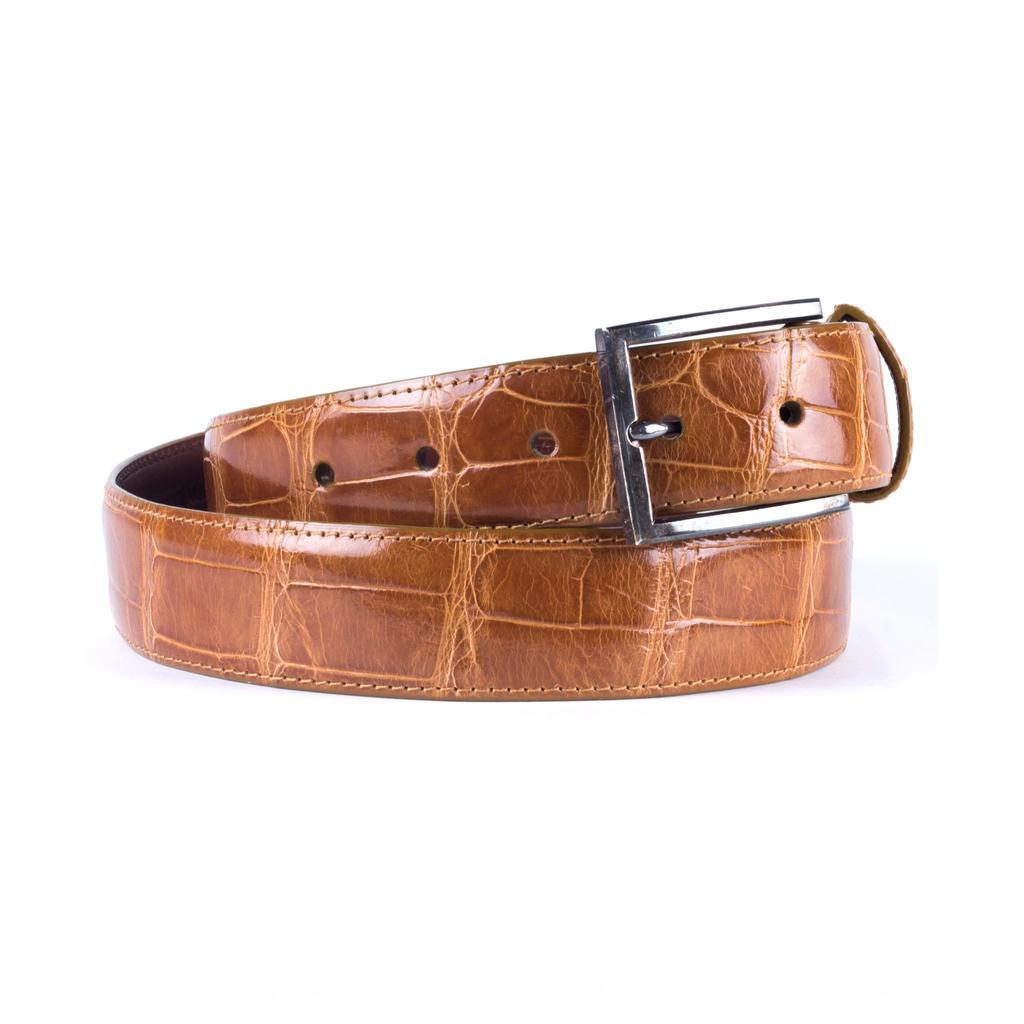In one or two sentences, can you explain what this image depicts? In this image I can see a leather belt. 